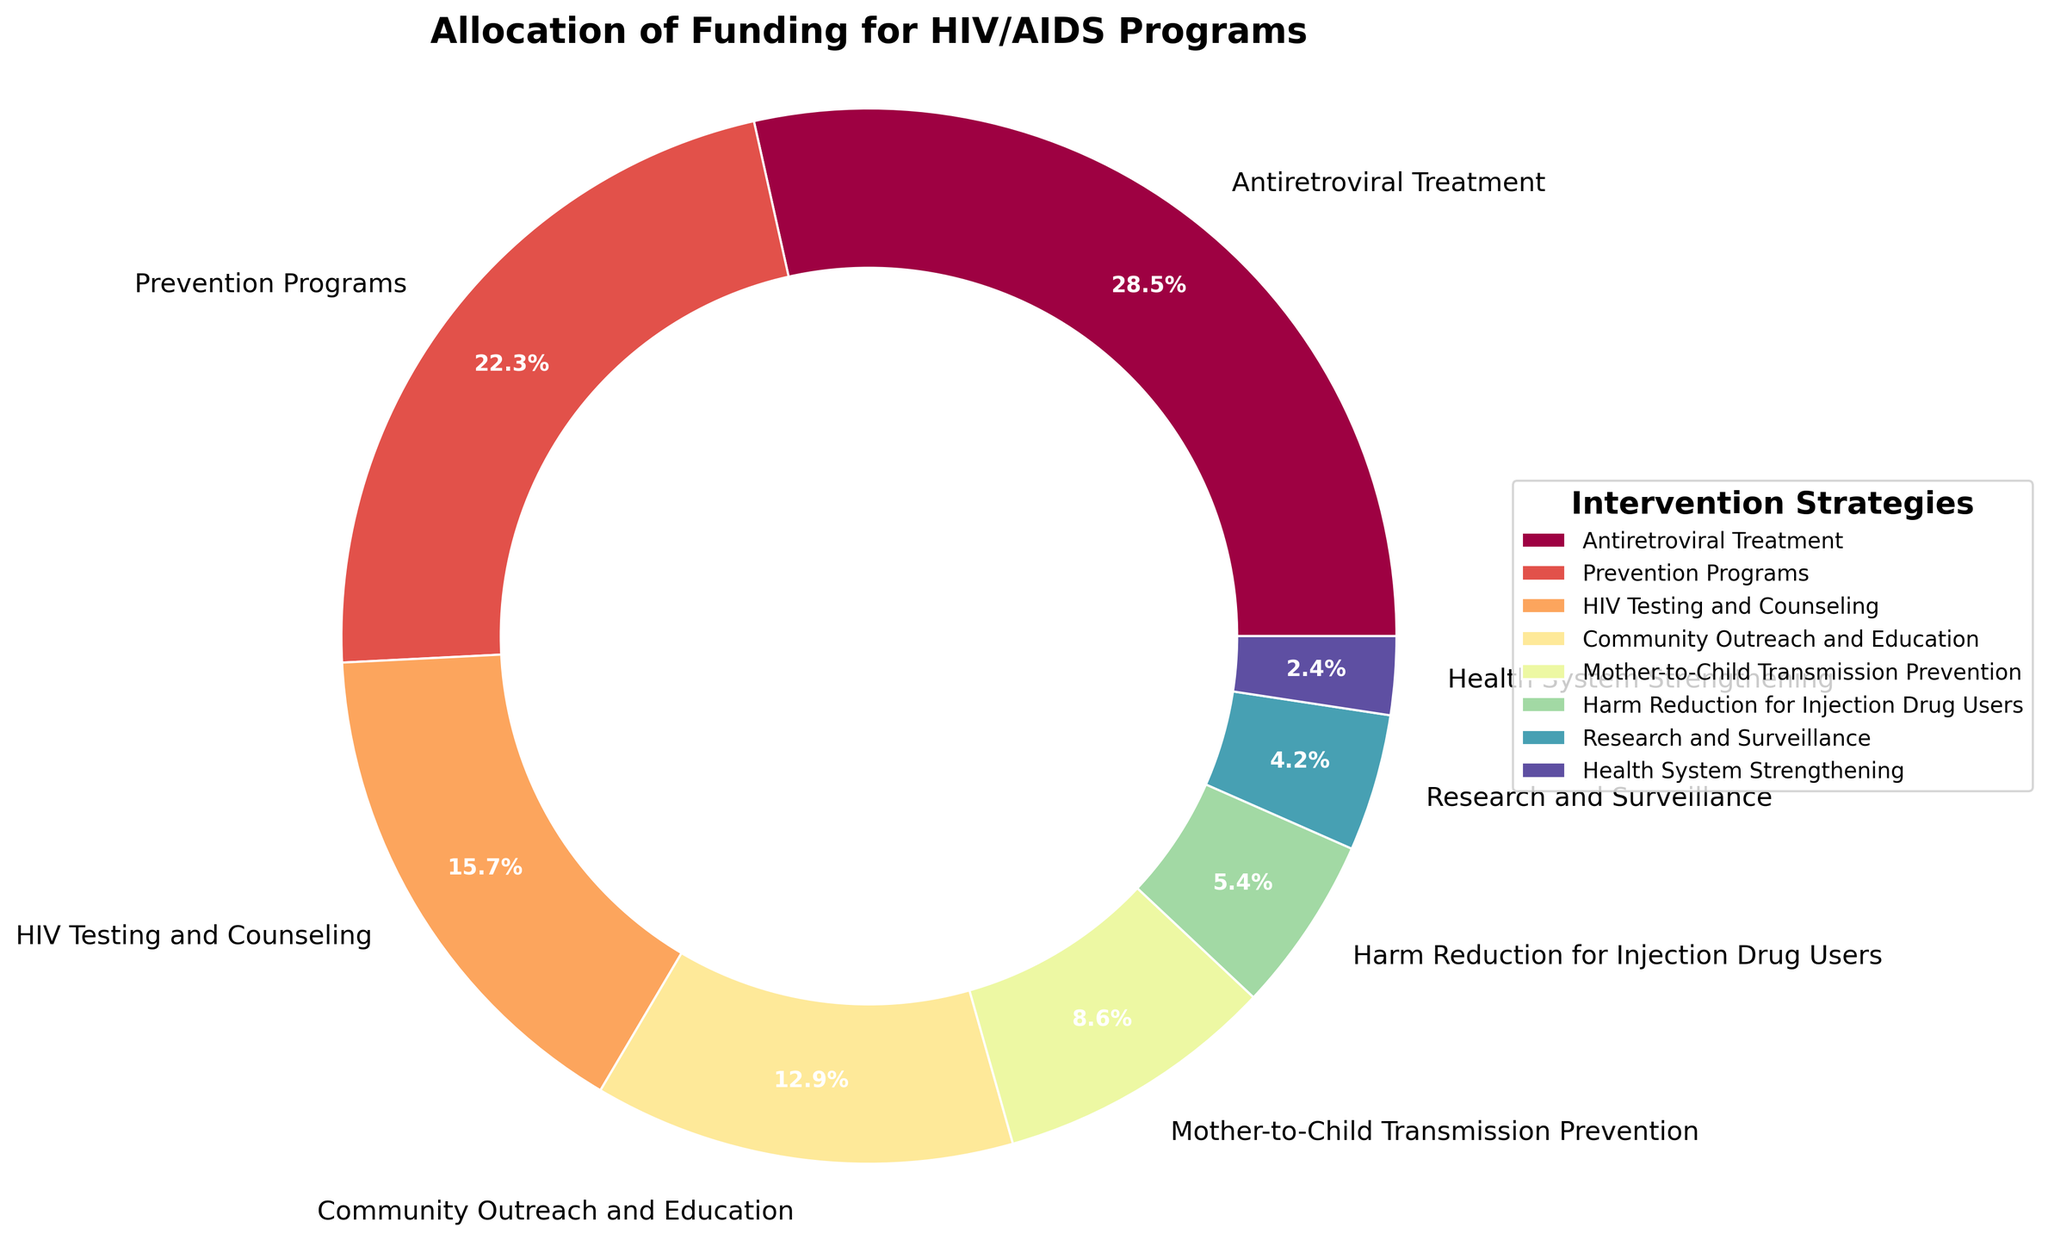What percentage of funding is allocated to the two highest-funded intervention strategies? Sum the percentages allocated to "Antiretroviral Treatment" (28.5%) and "Prevention Programs" (22.3%). 28.5 + 22.3 = 50.8
Answer: 50.8% Which intervention strategy receives the least funding? Identify the strategy with the smallest percentage in the pie chart. "Health System Strengthening" receives 2.4%, which is the lowest.
Answer: Health System Strengthening Is the funding for Mother-to-Child Transmission Prevention greater than the funding for Harm Reduction for Injection Drug Users? Compare the percentages: Mother-to-Child Transmission Prevention (8.6%) and Harm Reduction for Injection Drug Users (5.4%). 8.6 > 5.4. Yes, it is.
Answer: Yes How much more funding is allocated to Community Outreach and Education compared to Research and Surveillance? Subtract the percentage for Research and Surveillance (4.2%) from Community Outreach and Education (12.9%). 12.9 - 4.2 = 8.7
Answer: 8.7% What are the combined percentages for HIV Testing and Counseling and Harm Reduction for Injection Drug Users? Sum the percentages for HIV Testing and Counseling (15.7%) and Harm Reduction for Injection Drug Users (5.4%). 15.7 + 5.4 = 21.1
Answer: 21.1% Which segment has a larger portion, Research and Surveillance or Health System Strengthening? Compare the two segments by their percentages. Research and Surveillance has 4.2%, and Health System Strengthening has 2.4%. 4.2 > 2.4. Research and Surveillance has a larger portion.
Answer: Research and Surveillance Are the funding allocations for Prevention Programs and Community Outreach and Education summed together greater than the allocation for Antiretroviral Treatment? Combine the percentages for Prevention Programs (22.3%) and Community Outreach and Education (12.9%), then compare with Antiretroviral Treatment (28.5%). 22.3 + 12.9 = 35.2, and 35.2 > 28.5. Yes, they are greater.
Answer: Yes What is the average funding allocation percentage for Antiretroviral Treatment, Prevention Programs, and HIV Testing and Counseling? Calculate the average by summing the three percentages and dividing by the number of strategies: (28.5 + 22.3 + 15.7) / 3. 66.5 / 3 = 22.17
Answer: 22.17 What percentage of the funding is allocated to intervention strategies other than the two highest-funded ones? Subtract the sum of the two highest-funded percentages (50.8%) from 100%. 100 - 50.8 = 49.2
Answer: 49.2% Which intervention strategies have funding allocations above 10%, and what are their combined percentage allocations? Identify the strategies: Antiretroviral Treatment (28.5%), Prevention Programs (22.3%), and Community Outreach and Education (12.9%). Sum these percentages: 28.5 + 22.3 + 12.9 = 63.7
Answer: 63.7% 